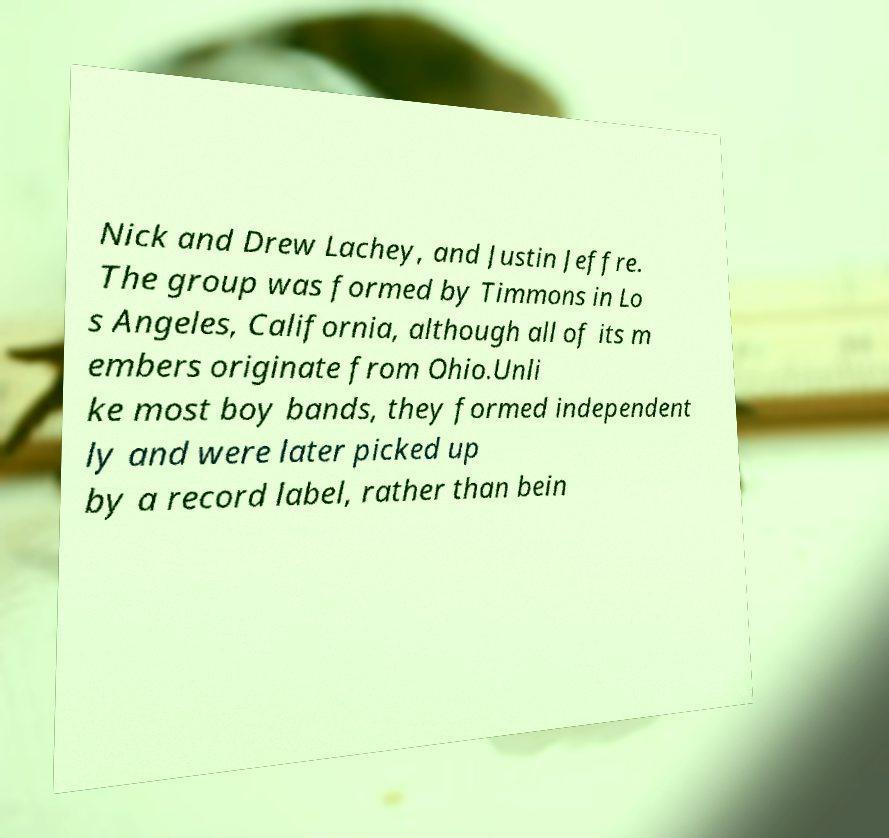What messages or text are displayed in this image? I need them in a readable, typed format. Nick and Drew Lachey, and Justin Jeffre. The group was formed by Timmons in Lo s Angeles, California, although all of its m embers originate from Ohio.Unli ke most boy bands, they formed independent ly and were later picked up by a record label, rather than bein 